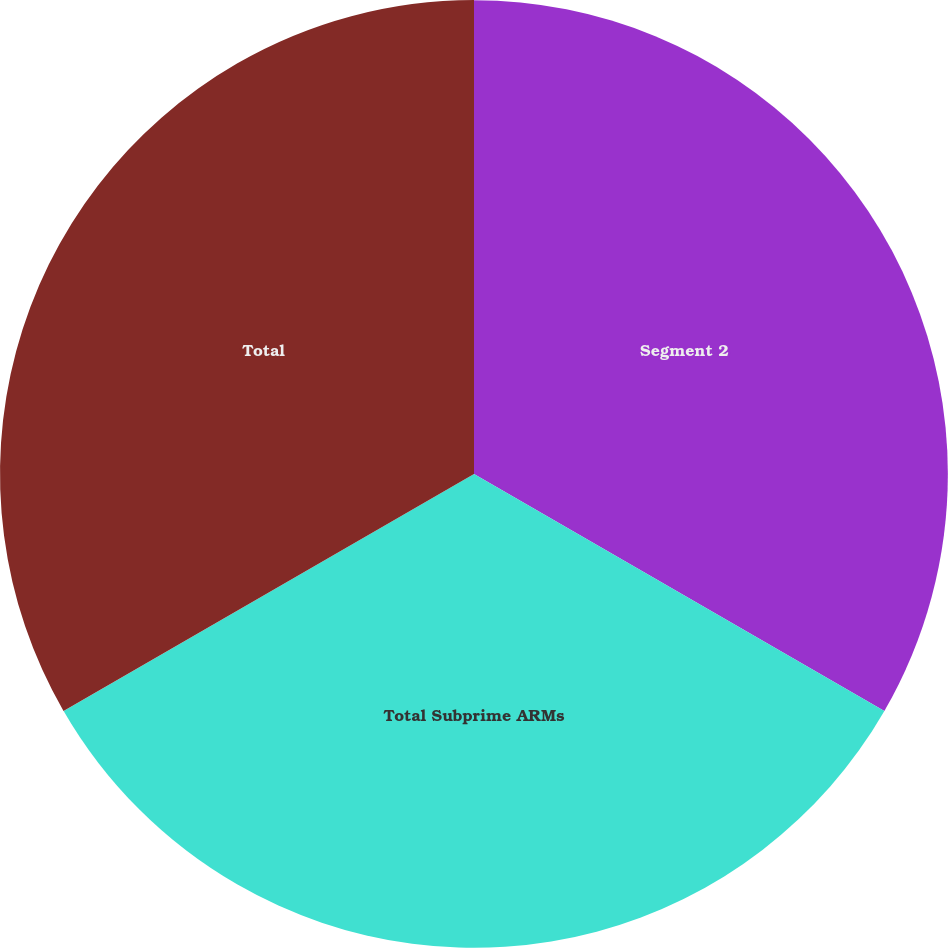<chart> <loc_0><loc_0><loc_500><loc_500><pie_chart><fcel>Segment 2<fcel>Total Subprime ARMs<fcel>Total<nl><fcel>33.33%<fcel>33.33%<fcel>33.34%<nl></chart> 